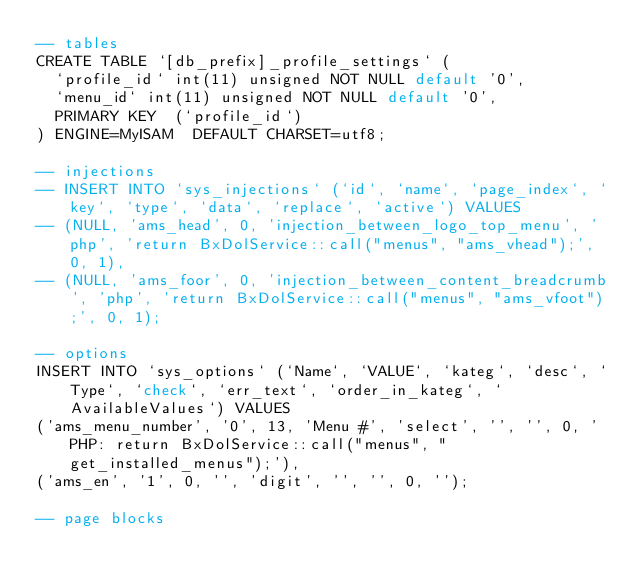<code> <loc_0><loc_0><loc_500><loc_500><_SQL_>-- tables
CREATE TABLE `[db_prefix]_profile_settings` (
  `profile_id` int(11) unsigned NOT NULL default '0',
  `menu_id` int(11) unsigned NOT NULL default '0',
  PRIMARY KEY  (`profile_id`)
) ENGINE=MyISAM  DEFAULT CHARSET=utf8;

-- injections
-- INSERT INTO `sys_injections` (`id`, `name`, `page_index`, `key`, `type`, `data`, `replace`, `active`) VALUES
-- (NULL, 'ams_head', 0, 'injection_between_logo_top_menu', 'php', 'return BxDolService::call("menus", "ams_vhead");', 0, 1),
-- (NULL, 'ams_foor', 0, 'injection_between_content_breadcrumb', 'php', 'return BxDolService::call("menus", "ams_vfoot");', 0, 1);

-- options
INSERT INTO `sys_options` (`Name`, `VALUE`, `kateg`, `desc`, `Type`, `check`, `err_text`, `order_in_kateg`, `AvailableValues`) VALUES 
('ams_menu_number', '0', 13, 'Menu #', 'select', '', '', 0, 'PHP: return BxDolService::call("menus", "get_installed_menus");'),
('ams_en', '1', 0, '', 'digit', '', '', 0, '');

-- page blocks</code> 